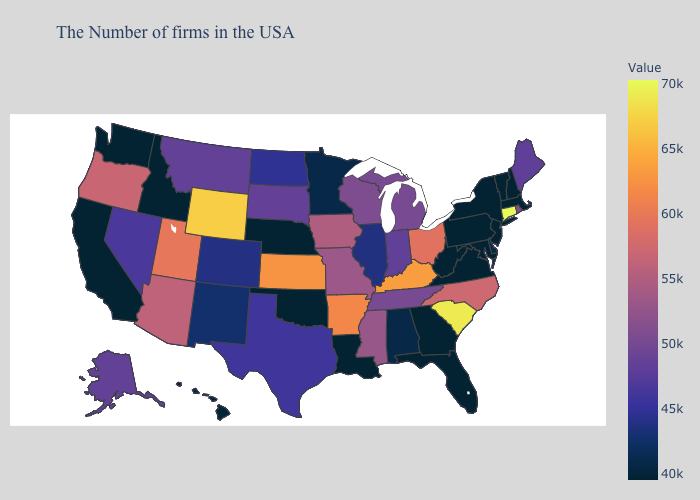Among the states that border Maryland , does Delaware have the lowest value?
Concise answer only. No. Does the map have missing data?
Concise answer only. No. Does Florida have a lower value than North Carolina?
Keep it brief. Yes. Among the states that border Massachusetts , which have the highest value?
Quick response, please. Connecticut. 